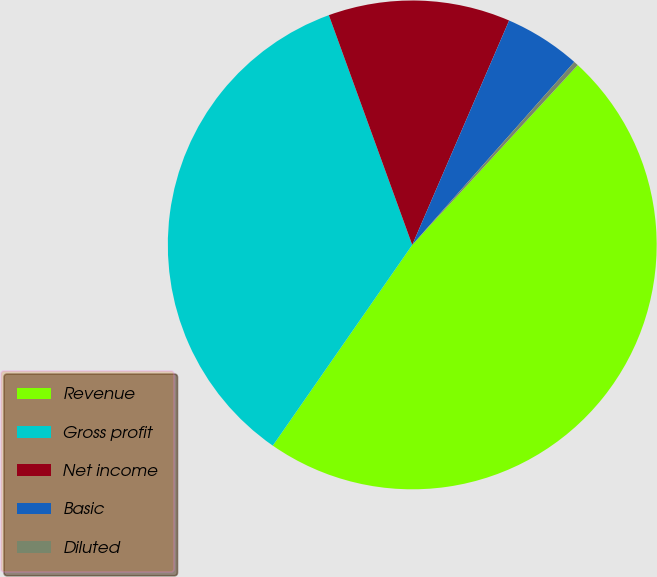Convert chart to OTSL. <chart><loc_0><loc_0><loc_500><loc_500><pie_chart><fcel>Revenue<fcel>Gross profit<fcel>Net income<fcel>Basic<fcel>Diluted<nl><fcel>47.83%<fcel>34.8%<fcel>12.03%<fcel>5.05%<fcel>0.3%<nl></chart> 